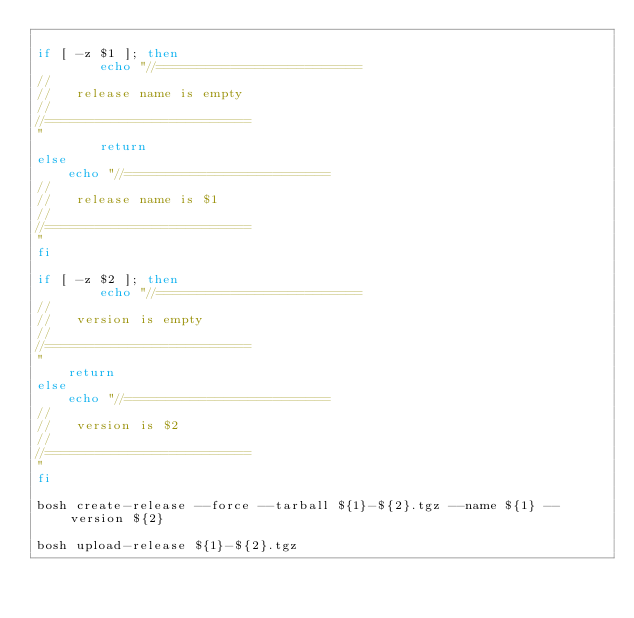Convert code to text. <code><loc_0><loc_0><loc_500><loc_500><_Bash_>
if [ -z $1 ]; then
        echo "//=========================
//
//   release name is empty 
//
//=========================
"
        return
else
    echo "//=========================
//
//   release name is $1
//
//=========================
"
fi

if [ -z $2 ]; then 
        echo "//=========================
//
//   version is empty 
//
//=========================
"
	return           
else
    echo "//=========================
//
//   version is $2
//
//=========================
"
fi

bosh create-release --force --tarball ${1}-${2}.tgz --name ${1} --version ${2}

bosh upload-release ${1}-${2}.tgz
</code> 